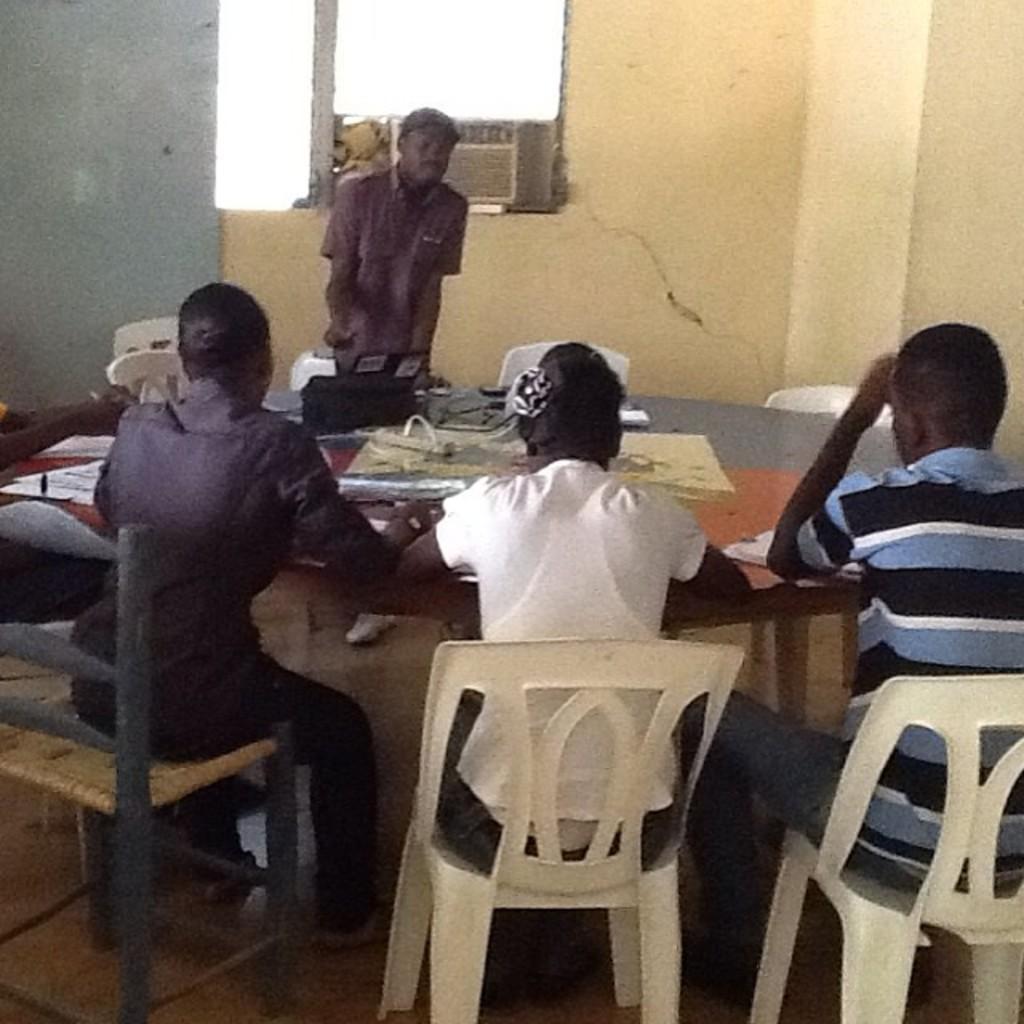Please provide a concise description of this image. In this image I can see the people sitting on the chair and one person is standing. In front of them there is a table with papers on it. And there is a window to the wall. 